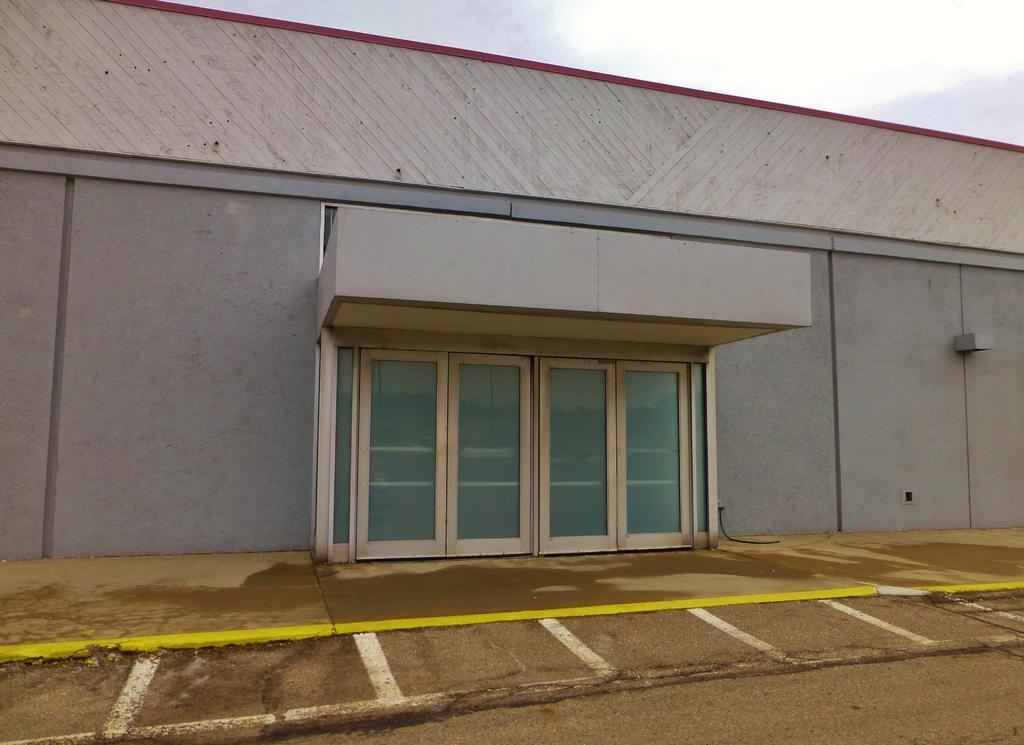What type of structure is in the image? There is a house in the image. What feature can be seen in the center of the house? There are glass doors in the center of the house. What is visible at the top of the image? The sky is visible at the top of the image. What is located at the bottom of the image? There is a road at the bottom of the image. How does the daughter feel about the expert's opinion on the airplane in the image? There is no daughter, expert, or airplane present in the image. 